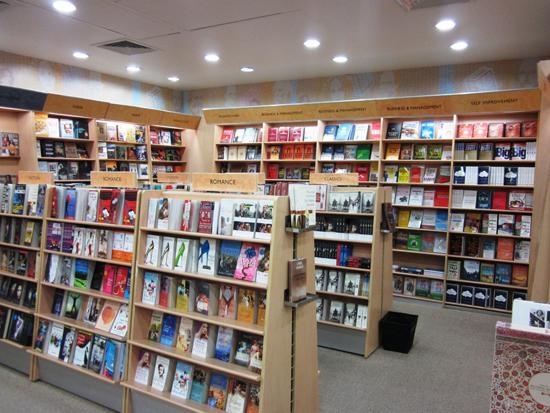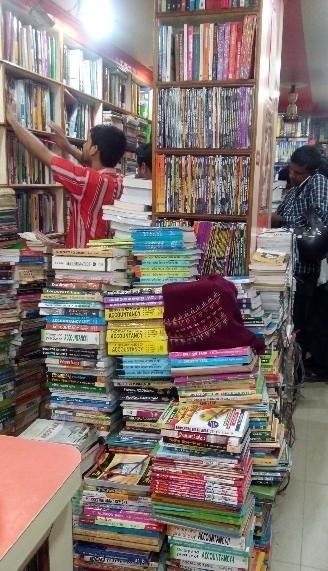The first image is the image on the left, the second image is the image on the right. Considering the images on both sides, is "There is at least one person that is walking in a bookstore near a light brown bookshelf." valid? Answer yes or no. Yes. The first image is the image on the left, the second image is the image on the right. For the images displayed, is the sentence "The shops are empty." factually correct? Answer yes or no. No. 